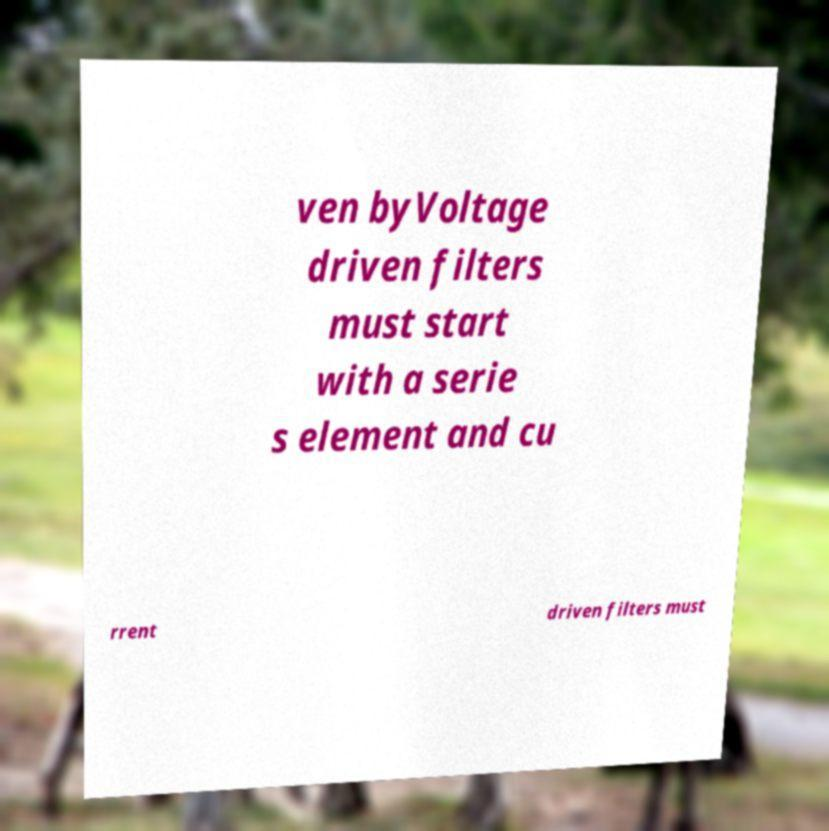What messages or text are displayed in this image? I need them in a readable, typed format. ven byVoltage driven filters must start with a serie s element and cu rrent driven filters must 